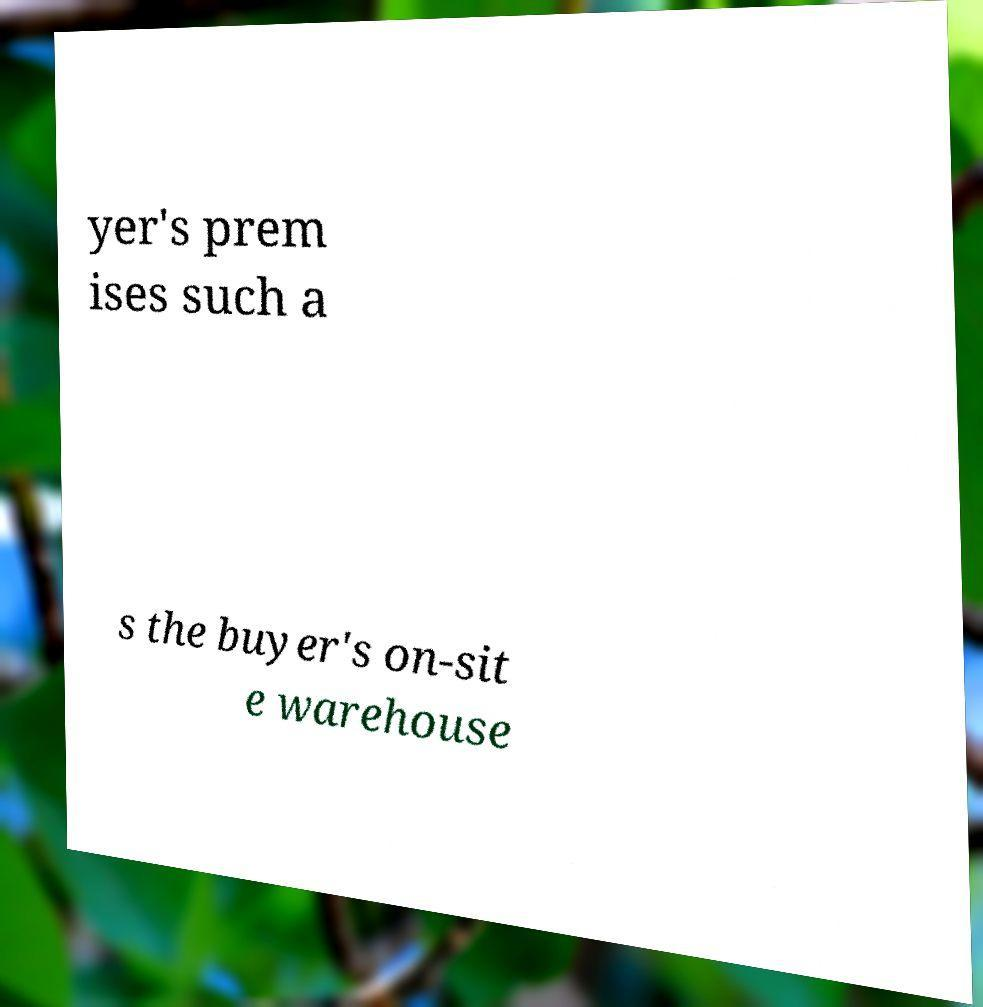Could you assist in decoding the text presented in this image and type it out clearly? yer's prem ises such a s the buyer's on-sit e warehouse 